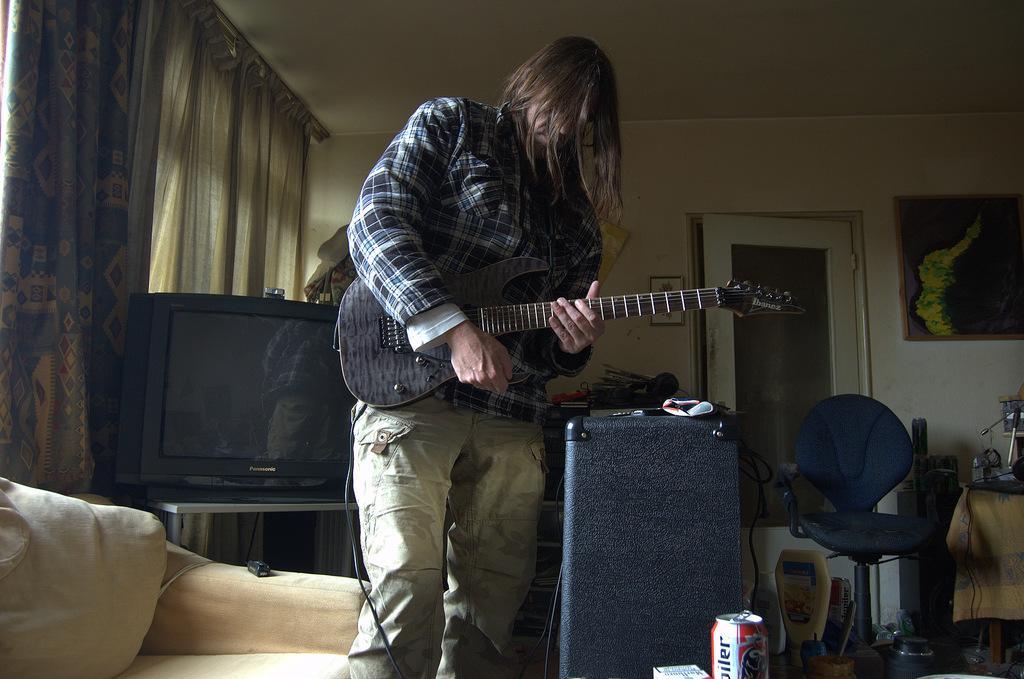Can you describe this image briefly? in a room a person is standing and playing guitar. right to him there is a chair, table. left to him there is a sofa and a television. at the back there are curtains. back of the room there is a wall on which there is a photo frame and a door. 